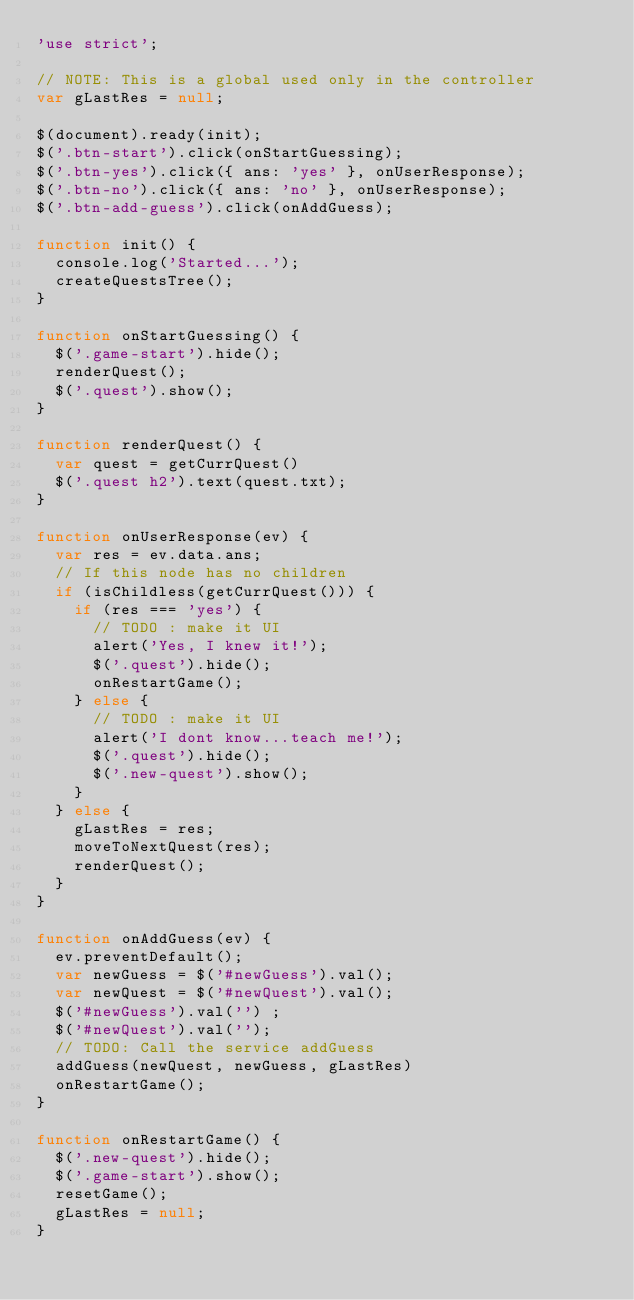<code> <loc_0><loc_0><loc_500><loc_500><_JavaScript_>'use strict';

// NOTE: This is a global used only in the controller
var gLastRes = null;

$(document).ready(init);
$('.btn-start').click(onStartGuessing);
$('.btn-yes').click({ ans: 'yes' }, onUserResponse);
$('.btn-no').click({ ans: 'no' }, onUserResponse);
$('.btn-add-guess').click(onAddGuess);

function init() {
  console.log('Started...');
  createQuestsTree();
}

function onStartGuessing() {
  $('.game-start').hide();
  renderQuest();
  $('.quest').show();
}

function renderQuest() {
  var quest = getCurrQuest()
  $('.quest h2').text(quest.txt);
}

function onUserResponse(ev) {
  var res = ev.data.ans;
  // If this node has no children
  if (isChildless(getCurrQuest())) {
    if (res === 'yes') {
      // TODO : make it UI
      alert('Yes, I knew it!');
      $('.quest').hide();
      onRestartGame();
    } else {
      // TODO : make it UI
      alert('I dont know...teach me!');
      $('.quest').hide();
      $('.new-quest').show();
    }
  } else {
    gLastRes = res;
    moveToNextQuest(res);
    renderQuest();
  }
}

function onAddGuess(ev) {
  ev.preventDefault();
  var newGuess = $('#newGuess').val();
  var newQuest = $('#newQuest').val();
  $('#newGuess').val('') ;
  $('#newQuest').val('');
  // TODO: Call the service addGuess
  addGuess(newQuest, newGuess, gLastRes)
  onRestartGame();
}

function onRestartGame() {
  $('.new-quest').hide();
  $('.game-start').show();
  resetGame();
  gLastRes = null;
}
</code> 